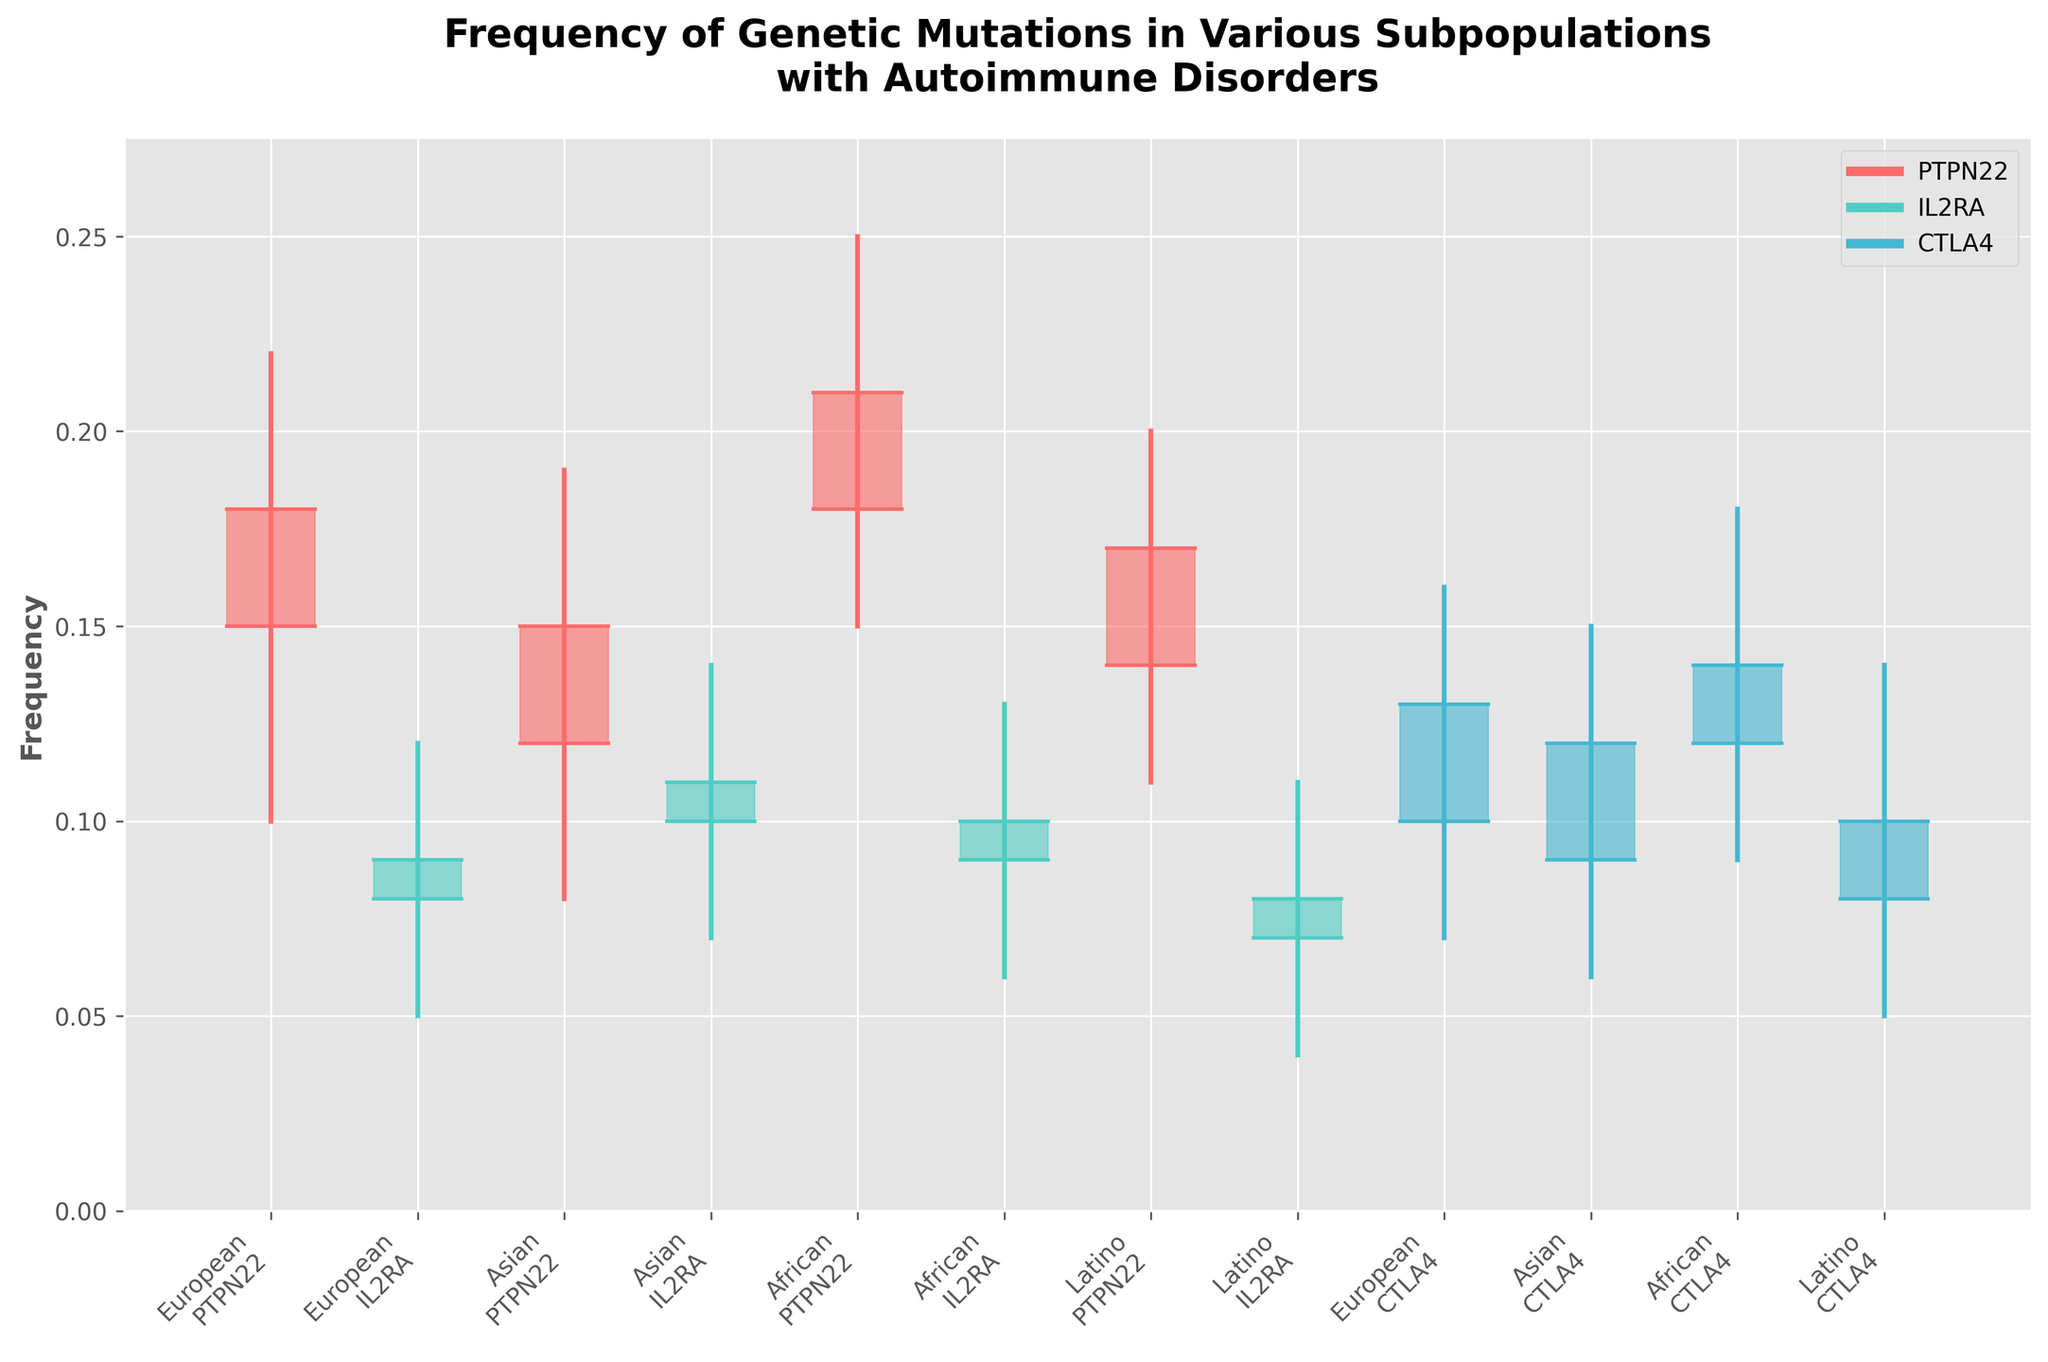What colors represent each mutation? The colors in the plot are represented in the legend. PTPN22 is shown in a red color, IL2RA in a light blue color, and CTLA4 in a blue color
Answer: PTPN22: red, IL2RA: light blue, CTLA4: blue Which subpopulation shows the highest frequency for the PTPN22 mutation? Looking at the highest values in the candlestick plot for the PTPN22 mutation bars, the African subpopulation shows the highest 'High' value at approximately 0.25
Answer: African What is the average 'Open' frequency for the IL2RA mutation across all subpopulations? IL2RA's 'Open' frequencies are: European (0.08), Asian (0.10), African (0.09), Latino (0.07). The average is calculated as (0.08 + 0.10 + 0.09 + 0.07) / 4 = 0.085
Answer: 0.085 Which subpopulation has the largest range in frequency for the CTLA4 mutation, and what is that range? For the CTLA4 mutation, we calculate the range for each subpopulation. European (0.16-0.07=0.09), Asian (0.15-0.06=0.09), African (0.18-0.09=0.09), Latino (0.14-0.05=0.09). All have the same range of 0.09
Answer: All subpopulations, 0.09 What is the median 'Close' frequency for the PTPN22 mutation across subpopulations? PTPN22 'Close' frequencies are: European (0.18), Asian (0.15), African (0.21), Latino (0.17). The values in order: 0.15, 0.17, 0.18, 0.21. The median is (0.17+0.18)/2 = 0.175
Answer: 0.175 Which mutation shows more consistent frequency between subpopulations when considering the 'High' values? Looking at the 'High' values: PTPN22 (0.22, 0.19, 0.25, 0.20), IL2RA (0.12, 0.14, 0.13, 0.11), CTLA4 (0.16, 0.15, 0.18, 0.14). The IL2RA mutation has a more consistent frequency range (from 0.11 to 0.14)
Answer: IL2RA Comparing European and Latino subpopulations, which mutation has a higher 'Low' frequency in the Latino group? For Latino and European subpopulations for each mutation: PTPN22 (0.11 vs 0.10), IL2RA (0.04 vs 0.05), CTLA4 (0.05 vs 0.07). PTPN22 has a higher 'Low' frequency in the Latino group (0.11 versus 0.10)
Answer: PTPN22 Which mutation has the widest range ('High' - 'Low') in the African subpopulation? For African subpopulations: PTPN22 (0.25-0.15=0.10), IL2RA (0.13-0.06=0.07), CTLA4 (0.18-0.09=0.09). PTPN22 has the widest range of 0.10
Answer: PTPN22 What is the average 'High' frequency value for CTLA4 mutation across all subpopulations? CTLA4 'High' frequencies are: European (0.16), Asian (0.15), African (0.18), Latino (0.14). The average is calculated as (0.16 + 0.15 + 0.18 + 0.14) / 4 = 0.1575
Answer: 0.1575 